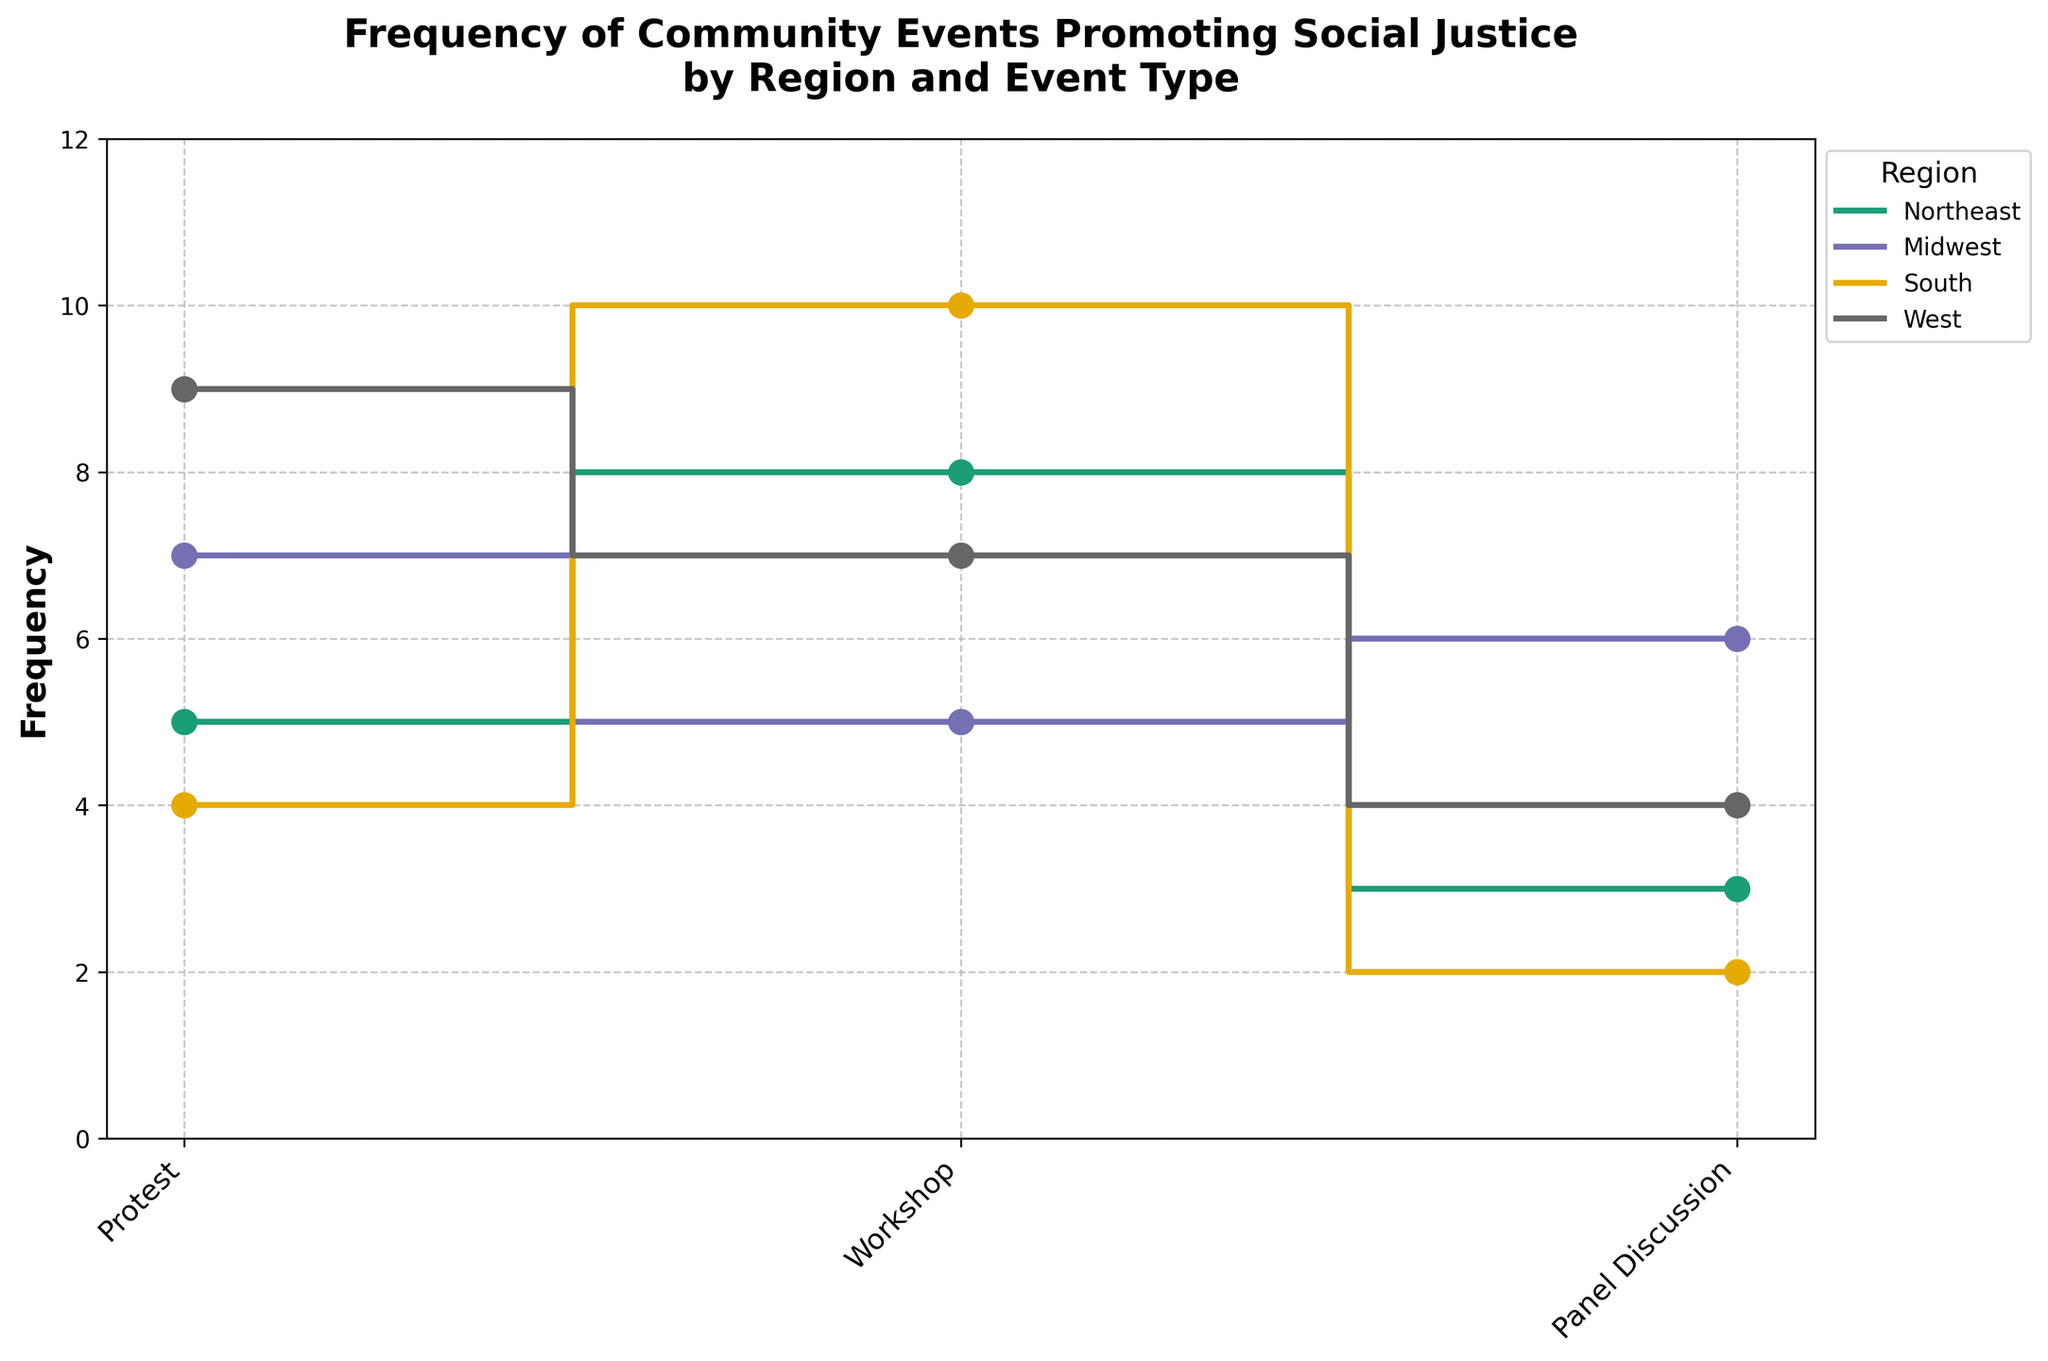How many regions are represented in the plot? The plot uses different colors to represent various distinct regions. By counting the distinct colors/labels in the legend, we identify that there are four different regions.
Answer: 4 Which region has the highest frequency of events in January? The stair plot shows lines with markers for each region. The height of the step for January indicates the frequency of events. The West region has the highest step for January.
Answer: West What type of event has the highest frequency in the South region? Look for the steps corresponding to the South region (usually indicated by a specific color) and compare their heights. The highest point corresponds to Workshop events in February.
Answer: Workshop What's the total frequency of Panel Discussions across all regions in March? Sum up the frequencies of Panel Discussions in March across all regions: 3 (Northeast) + 6 (Midwest) + 2 (South) + 4 (West) = 15.
Answer: 15 Which region had more Protest events in January, Midwest or South? Compare the height of the step for Protest events in January for the Midwest and South regions. The Midwest has a higher step than the South.
Answer: Midwest What is the overall trend of Workshop events across the regions? Observe the pattern of steps for Workshop events. They peak in February across all regions, indicating high engagement in Workshop events during that month.
Answer: Peak in February How does the frequency of Workshop events in the Northeast compare to the Midwest? Compare the heights of the steps for Workshop events for both Northeast and Midwest regions. The Northeast has a higher frequency (8) compared to the Midwest (5).
Answer: Northeast Which month sees the lowest frequency of events across all regions? Analyse the heights of the steps for each month. March generally has the lowest frequencies for events across all regions.
Answer: March Does any region have the same frequency for Protest and Workshop events? If yes, which one? Compare the heights of the steps for Protest and Workshop events within each region. According to the plot, no region has the same frequency for these two event types.
Answer: No What’s the combined frequency of all events in the Northeast region? Add up the frequencies of all event types in the Northeast: 5 (Protest) + 8 (Workshop) + 3 (Panel Discussion) = 16.
Answer: 16 